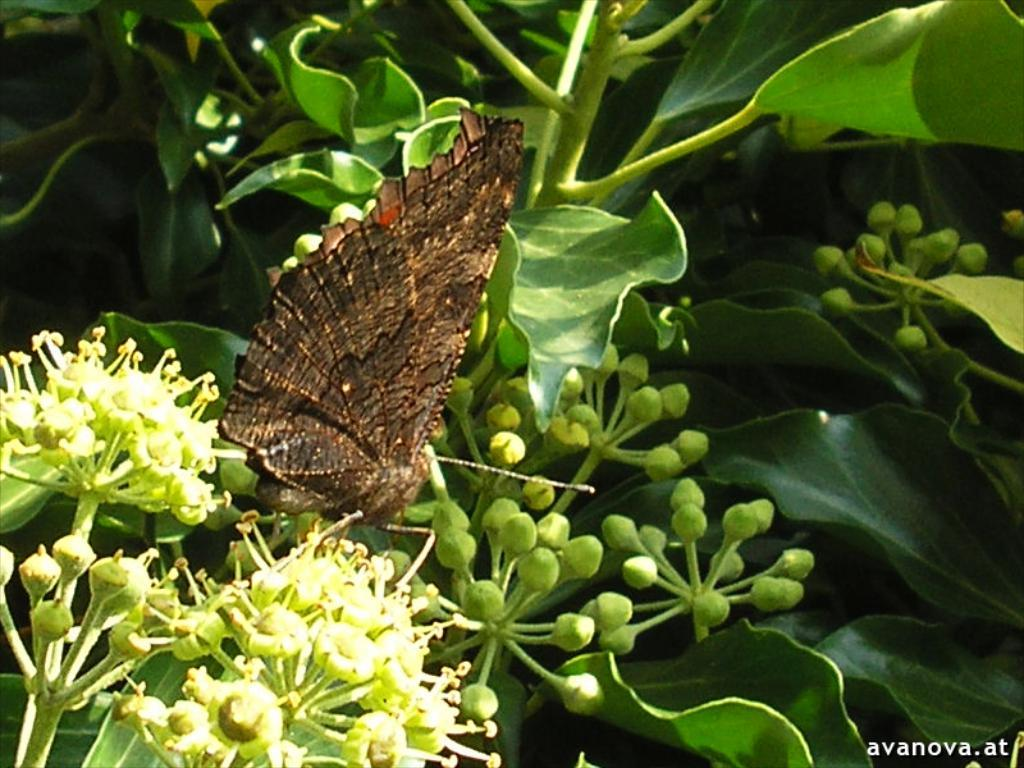What type of plants can be seen in the image? There are flowers and buds in the image. Is there any wildlife present in the image? Yes, there is a butterfly on the flowers. What color are the leaves in the image? The leaves in the image are green. Is there any text or marking in the image? Yes, there is a watermark in the bottom right corner of the image. How many sisters are depicted in the image? There are no sisters present in the image. What type of art is being created in the image? The image does not depict any art being created. Is there a bottle visible in the image? There is no bottle present in the image. 